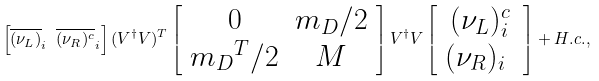<formula> <loc_0><loc_0><loc_500><loc_500>\left [ \overline { ( \nu _ { L } ) } _ { i } \ \overline { ( \nu _ { R } ) ^ { c } } _ { i } \right ] ( V ^ { \dag } V ) ^ { T } \left [ \begin{array} { c c } 0 & m _ { D } / 2 \\ { m _ { D } } ^ { T } / 2 & M \\ \end{array} \right ] V ^ { \dag } V \left [ \begin{array} { c } ( \nu _ { L } ) ^ { c } _ { i } \\ ( \nu _ { R } ) _ { i } \ \\ \end{array} \right ] + H . c . ,</formula> 